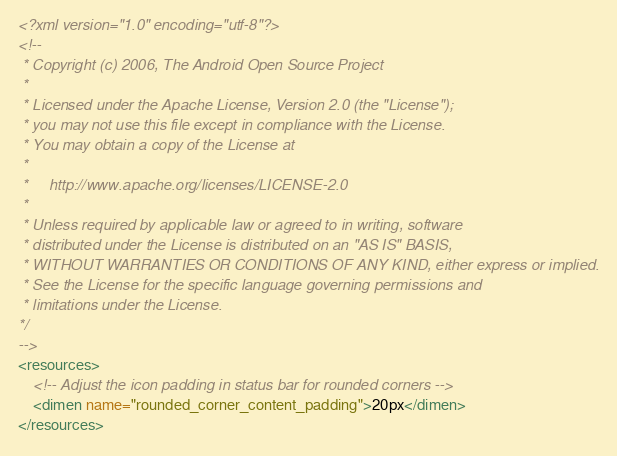<code> <loc_0><loc_0><loc_500><loc_500><_XML_><?xml version="1.0" encoding="utf-8"?>
<!--
 * Copyright (c) 2006, The Android Open Source Project
 *
 * Licensed under the Apache License, Version 2.0 (the "License");
 * you may not use this file except in compliance with the License.
 * You may obtain a copy of the License at
 *
 *     http://www.apache.org/licenses/LICENSE-2.0
 *
 * Unless required by applicable law or agreed to in writing, software
 * distributed under the License is distributed on an "AS IS" BASIS,
 * WITHOUT WARRANTIES OR CONDITIONS OF ANY KIND, either express or implied.
 * See the License for the specific language governing permissions and
 * limitations under the License.
*/
-->
<resources>
    <!-- Adjust the icon padding in status bar for rounded corners --> 
    <dimen name="rounded_corner_content_padding">20px</dimen>
</resources></code> 